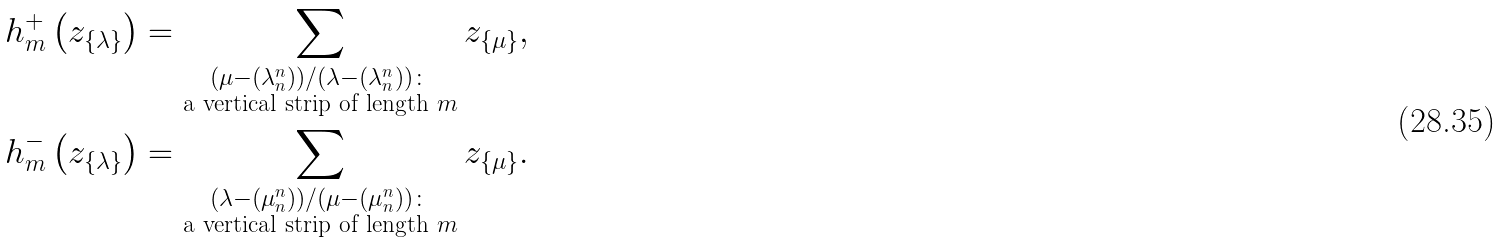Convert formula to latex. <formula><loc_0><loc_0><loc_500><loc_500>h ^ { + } _ { m } \left ( z _ { \{ \lambda \} } \right ) & = \sum _ { \substack { ( \mu - ( \lambda _ { n } ^ { n } ) ) / ( \lambda - ( \lambda _ { n } ^ { n } ) ) \colon \\ \text {a vertical strip of length $m$} } } z _ { \{ \mu \} } , \\ h ^ { - } _ { m } \left ( z _ { \{ \lambda \} } \right ) & = \sum _ { \substack { ( \lambda - ( \mu _ { n } ^ { n } ) ) / ( \mu - ( \mu _ { n } ^ { n } ) ) \colon \\ \text {a vertical strip of length $m$} } } z _ { \{ \mu \} } .</formula> 